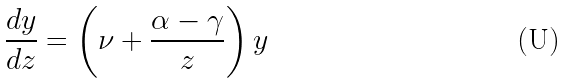Convert formula to latex. <formula><loc_0><loc_0><loc_500><loc_500>& \frac { d y } { d z } = \left ( \nu + \frac { \alpha - \gamma } { z } \right ) y</formula> 